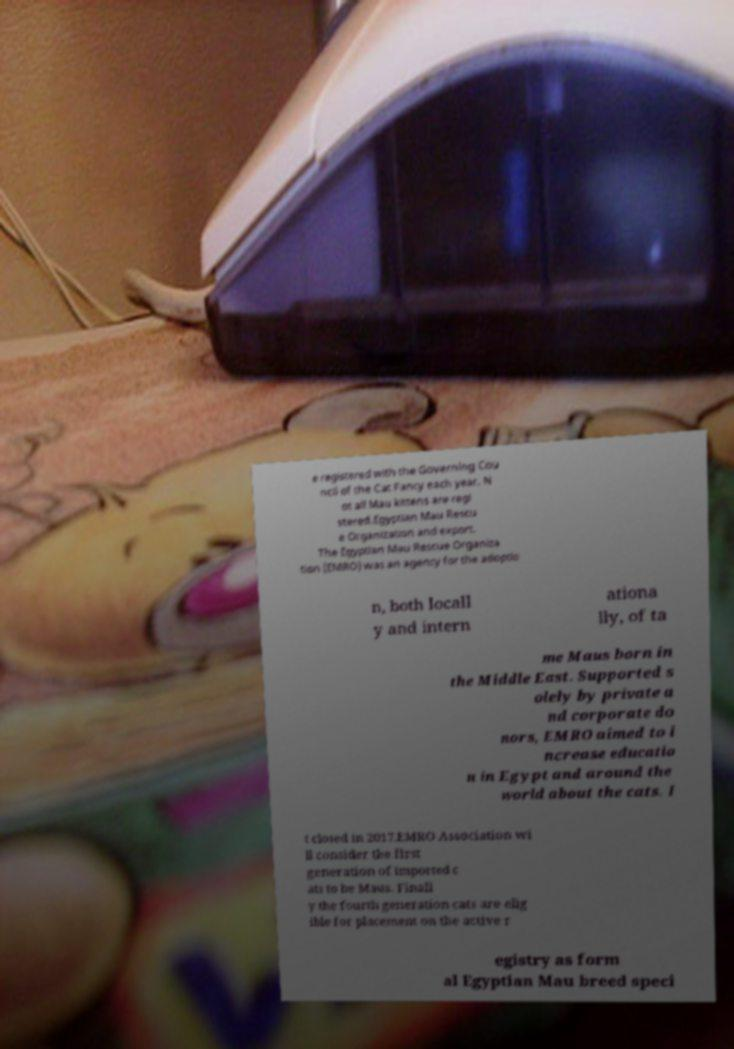I need the written content from this picture converted into text. Can you do that? e registered with the Governing Cou ncil of the Cat Fancy each year. N ot all Mau kittens are regi stered.Egyptian Mau Rescu e Organization and export. The Egyptian Mau Rescue Organiza tion (EMRO) was an agency for the adoptio n, both locall y and intern ationa lly, of ta me Maus born in the Middle East. Supported s olely by private a nd corporate do nors, EMRO aimed to i ncrease educatio n in Egypt and around the world about the cats. I t closed in 2017.EMRO Association wi ll consider the first generation of imported c ats to be Maus. Finall y the fourth generation cats are elig ible for placement on the active r egistry as form al Egyptian Mau breed speci 